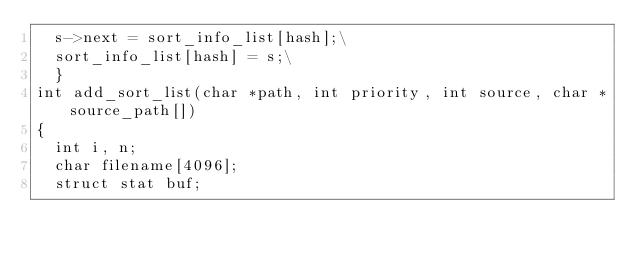<code> <loc_0><loc_0><loc_500><loc_500><_C_>	s->next = sort_info_list[hash];\
	sort_info_list[hash] = s;\
	}
int add_sort_list(char *path, int priority, int source, char *source_path[])
{
	int i, n;
	char filename[4096];
	struct stat buf;
</code> 